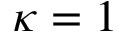Convert formula to latex. <formula><loc_0><loc_0><loc_500><loc_500>\kappa = 1</formula> 